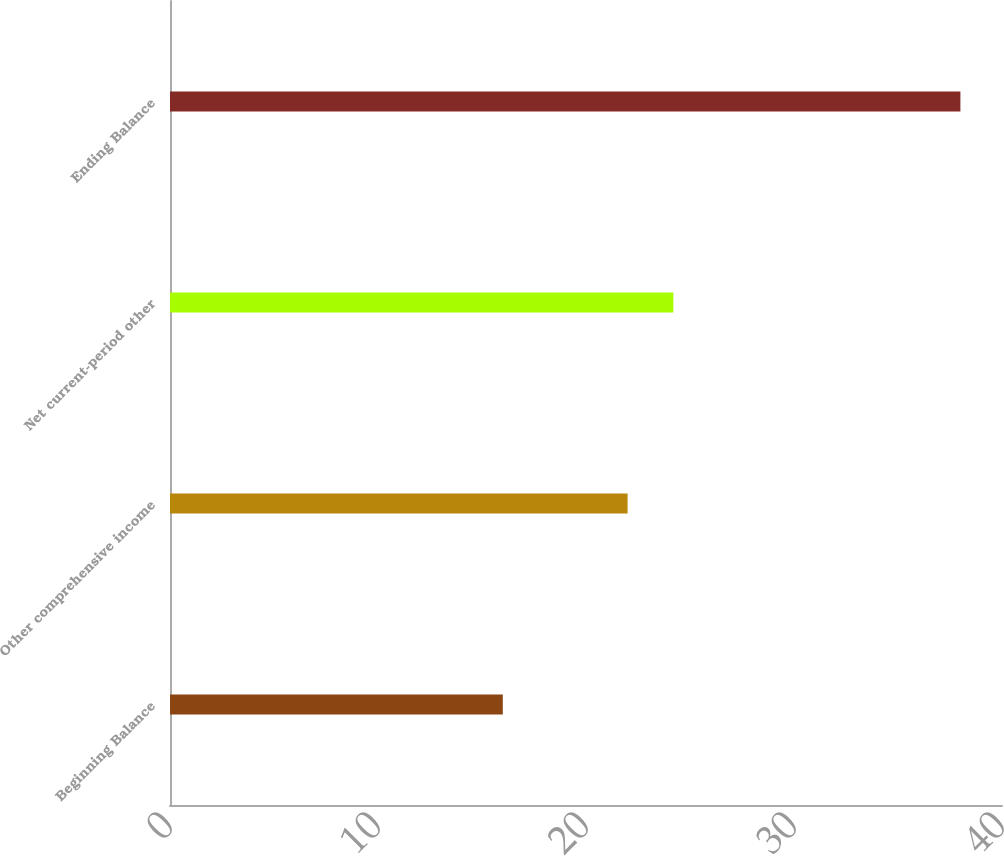<chart> <loc_0><loc_0><loc_500><loc_500><bar_chart><fcel>Beginning Balance<fcel>Other comprehensive income<fcel>Net current-period other<fcel>Ending Balance<nl><fcel>16<fcel>22<fcel>24.2<fcel>38<nl></chart> 